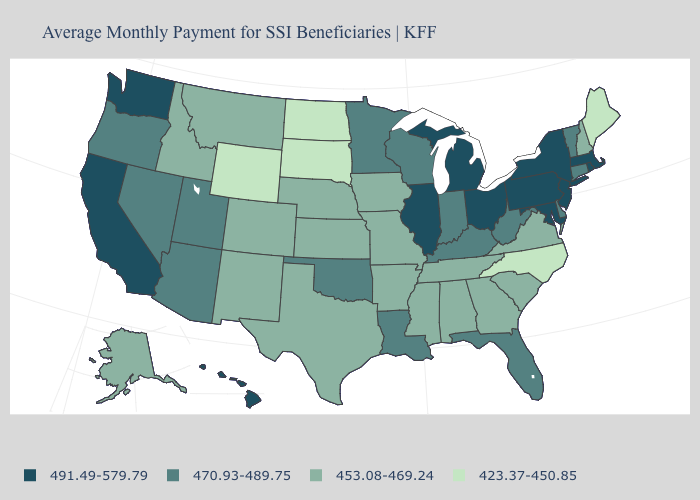Name the states that have a value in the range 423.37-450.85?
Be succinct. Maine, North Carolina, North Dakota, South Dakota, Wyoming. What is the highest value in states that border Maine?
Quick response, please. 453.08-469.24. What is the highest value in states that border California?
Be succinct. 470.93-489.75. What is the value of Texas?
Write a very short answer. 453.08-469.24. What is the value of Kentucky?
Keep it brief. 470.93-489.75. What is the value of Pennsylvania?
Keep it brief. 491.49-579.79. What is the value of Massachusetts?
Concise answer only. 491.49-579.79. What is the lowest value in the West?
Short answer required. 423.37-450.85. What is the value of Delaware?
Short answer required. 470.93-489.75. What is the value of Oregon?
Concise answer only. 470.93-489.75. Name the states that have a value in the range 470.93-489.75?
Write a very short answer. Arizona, Connecticut, Delaware, Florida, Indiana, Kentucky, Louisiana, Minnesota, Nevada, Oklahoma, Oregon, Utah, Vermont, West Virginia, Wisconsin. Does the first symbol in the legend represent the smallest category?
Answer briefly. No. What is the lowest value in states that border South Carolina?
Be succinct. 423.37-450.85. What is the highest value in states that border Maine?
Write a very short answer. 453.08-469.24. 